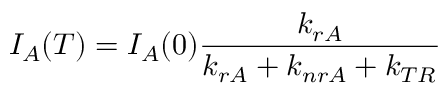Convert formula to latex. <formula><loc_0><loc_0><loc_500><loc_500>I _ { A } ( T ) = I _ { A } ( 0 ) \frac { k _ { r A } } { k _ { r A } + k _ { n r A } + k _ { T R } }</formula> 